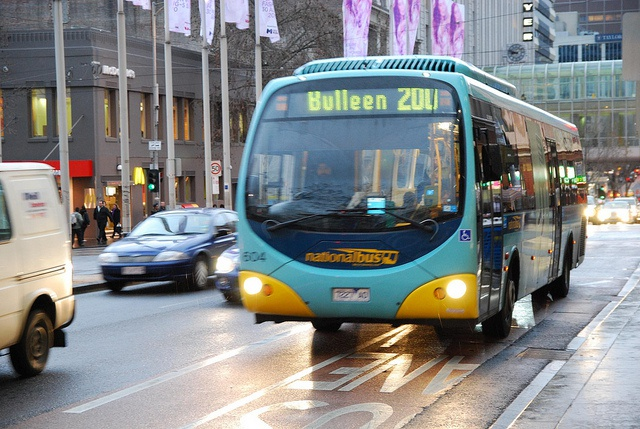Describe the objects in this image and their specific colors. I can see bus in gray, black, teal, and darkgray tones, truck in gray, tan, lightgray, black, and darkgray tones, car in gray, black, and lightblue tones, car in gray, white, black, and darkgray tones, and people in gray, blue, and darkblue tones in this image. 